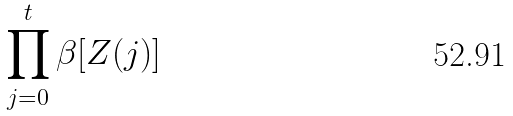<formula> <loc_0><loc_0><loc_500><loc_500>\prod _ { j = 0 } ^ { t } \beta [ Z ( j ) ]</formula> 